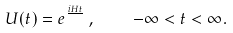<formula> <loc_0><loc_0><loc_500><loc_500>U ( t ) = e ^ { \frac { i H t } { } } \, , \quad - \infty < t < \infty .</formula> 